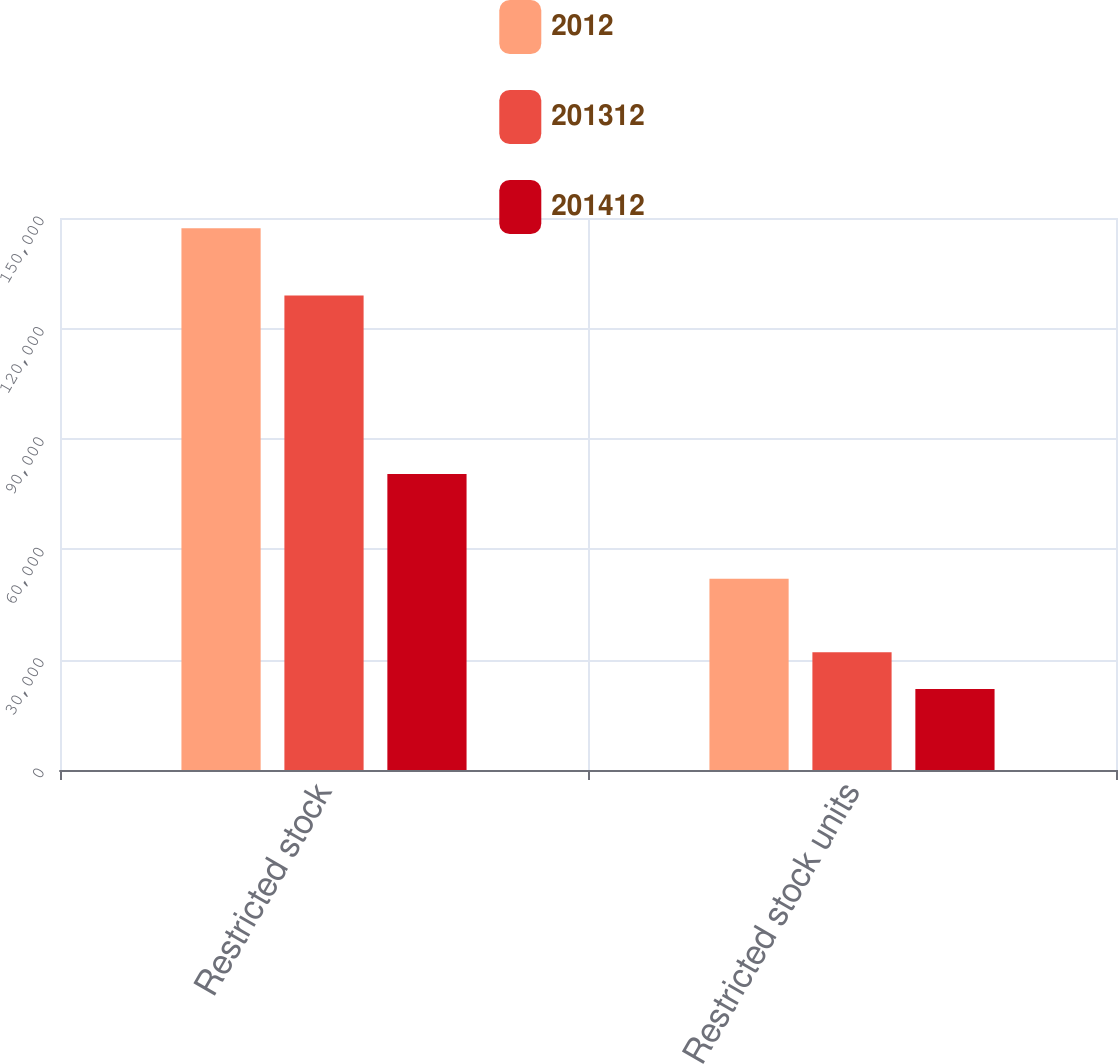Convert chart to OTSL. <chart><loc_0><loc_0><loc_500><loc_500><stacked_bar_chart><ecel><fcel>Restricted stock<fcel>Restricted stock units<nl><fcel>2012<fcel>147221<fcel>52000<nl><fcel>201312<fcel>128923<fcel>32000<nl><fcel>201412<fcel>80460<fcel>22000<nl></chart> 